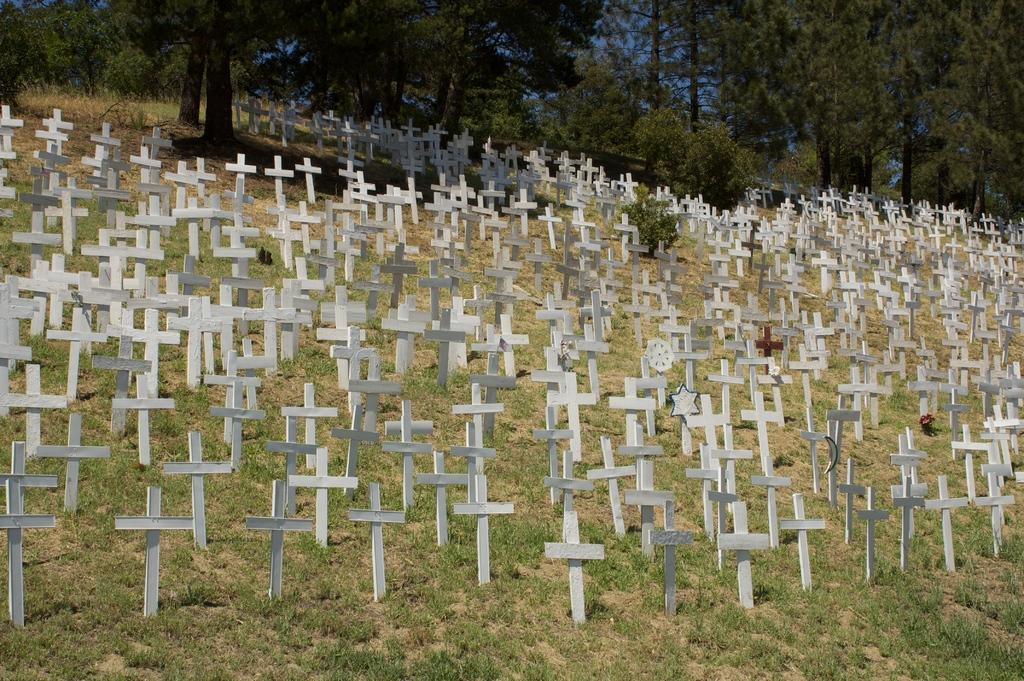What symbols can be seen in the image? There are cross symbols in the image. What type of vegetation is present in the image? There is grass, plants, and trees in the image. What can be seen in the background of the image? The sky is visible in the background of the image. Can you tell me how many planes are flying in the image? There are no planes visible in the image; it only features cross symbols, grass, plants, trees, and the sky. Are there any fairies visible in the image? There are no fairies present in the image. 